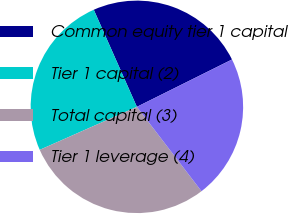Convert chart. <chart><loc_0><loc_0><loc_500><loc_500><pie_chart><fcel>Common equity tier 1 capital<fcel>Tier 1 capital (2)<fcel>Total capital (3)<fcel>Tier 1 leverage (4)<nl><fcel>24.3%<fcel>24.98%<fcel>28.77%<fcel>21.95%<nl></chart> 